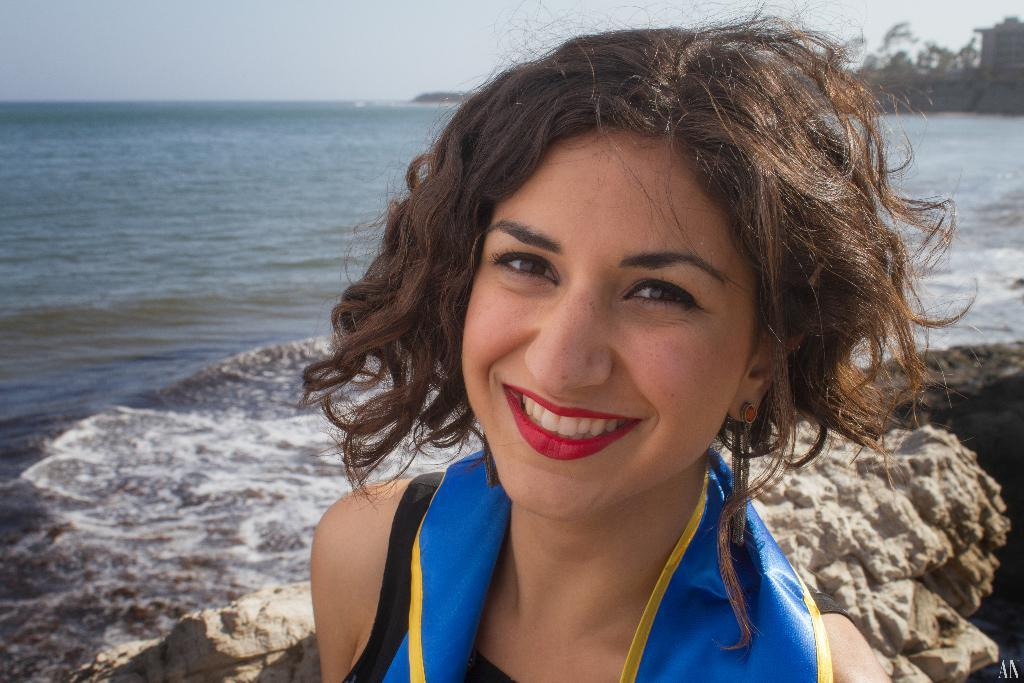Who is present in the image? There is a woman in the image. What is the woman's expression in the image? The woman is smiling in the image. What can be seen in the background of the image? There are rocks, tides of the ocean, trees, and the sky visible in the background of the image. What type of rhythm does the woman exhibit in the image? There is no mention of rhythm or any activity that would suggest a rhythm in the image. The woman is simply smiling, and the focus is on her expression and the background elements. 